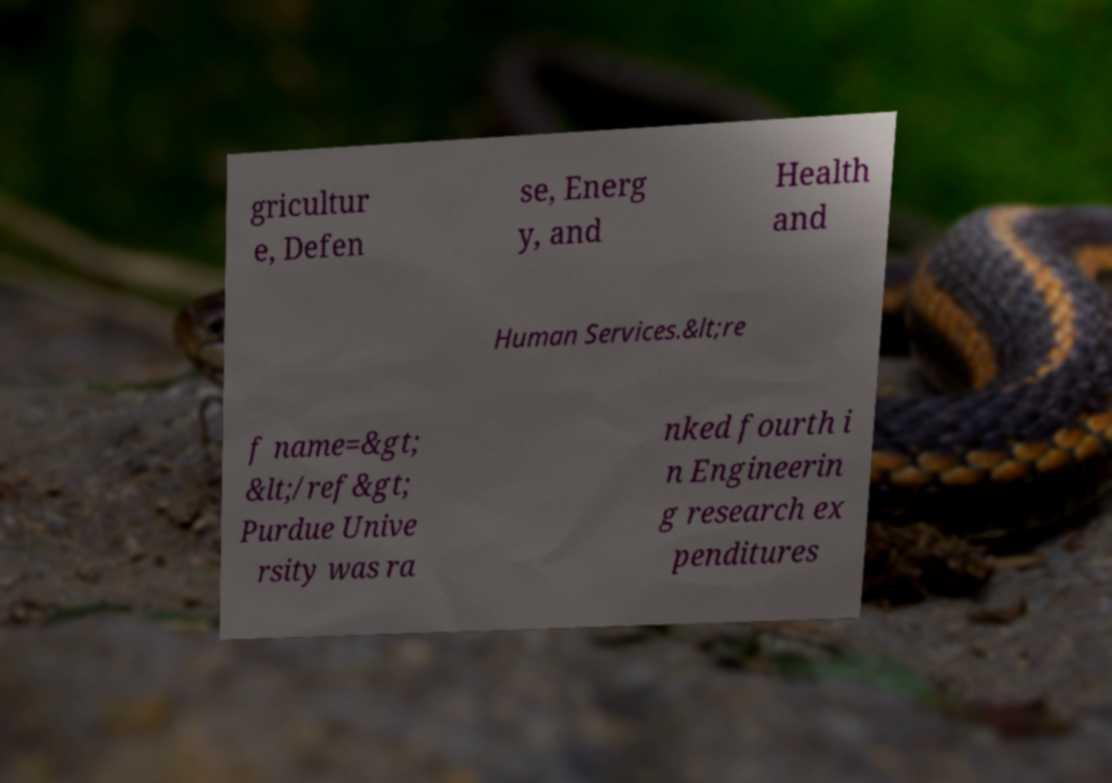For documentation purposes, I need the text within this image transcribed. Could you provide that? gricultur e, Defen se, Energ y, and Health and Human Services.&lt;re f name=&gt; &lt;/ref&gt; Purdue Unive rsity was ra nked fourth i n Engineerin g research ex penditures 